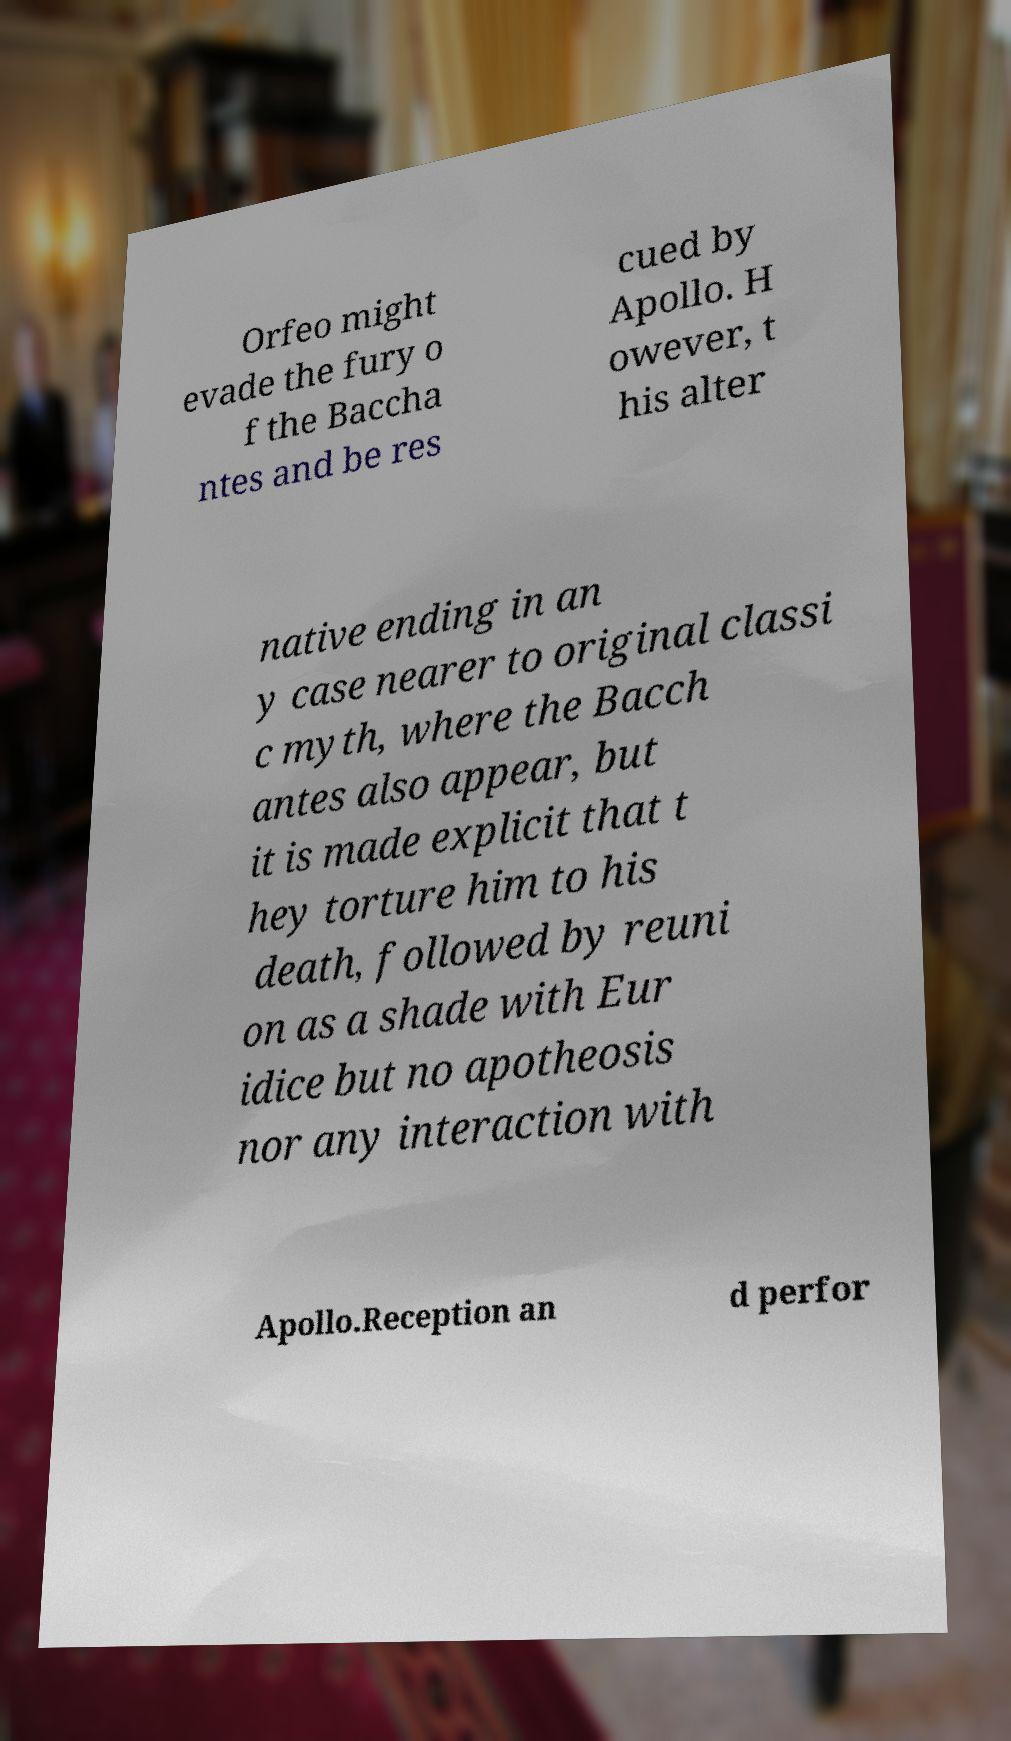There's text embedded in this image that I need extracted. Can you transcribe it verbatim? Orfeo might evade the fury o f the Baccha ntes and be res cued by Apollo. H owever, t his alter native ending in an y case nearer to original classi c myth, where the Bacch antes also appear, but it is made explicit that t hey torture him to his death, followed by reuni on as a shade with Eur idice but no apotheosis nor any interaction with Apollo.Reception an d perfor 